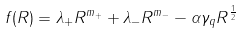<formula> <loc_0><loc_0><loc_500><loc_500>f ( R ) = \lambda _ { + } R ^ { m _ { + } } + \lambda _ { - } R ^ { m _ { - } } - \alpha \gamma _ { q } R ^ { \frac { 1 } { 2 } }</formula> 